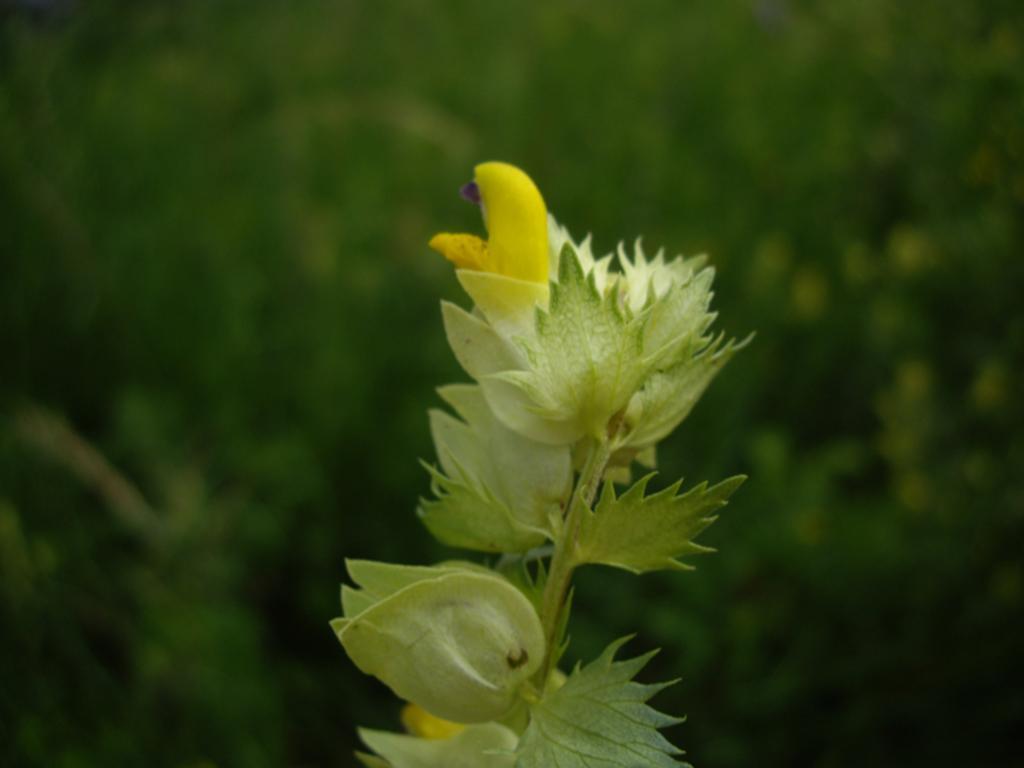Could you give a brief overview of what you see in this image? In this image we can see a plant and flowers and in the background the image is blurred. 